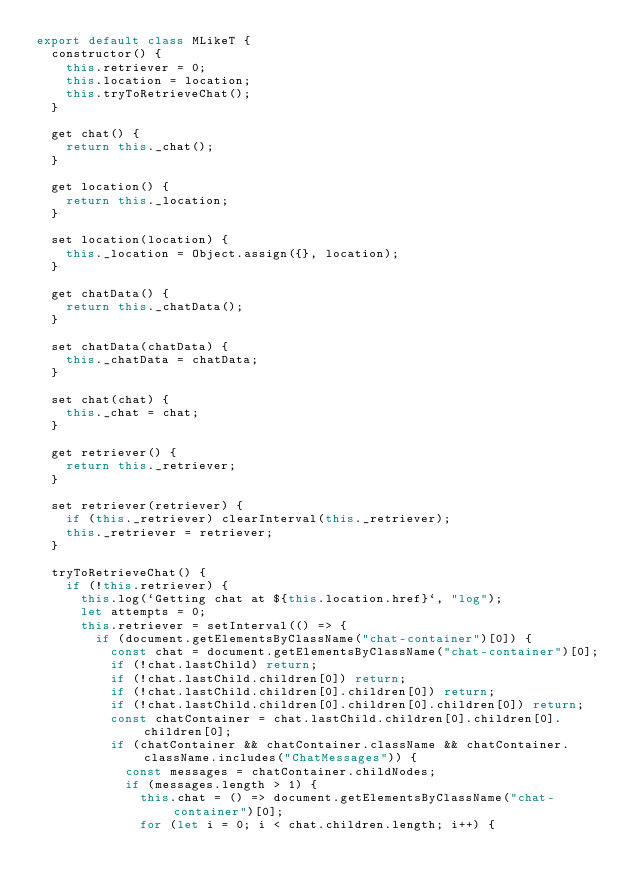Convert code to text. <code><loc_0><loc_0><loc_500><loc_500><_JavaScript_>export default class MLikeT {
  constructor() {
    this.retriever = 0;
    this.location = location;
    this.tryToRetrieveChat();
  }

  get chat() {
    return this._chat();
  }

  get location() {
    return this._location;
  }

  set location(location) {
    this._location = Object.assign({}, location);
  }

  get chatData() {
    return this._chatData();
  }

  set chatData(chatData) {
    this._chatData = chatData;
  }

  set chat(chat) {
    this._chat = chat;
  }

  get retriever() {
    return this._retriever;
  }

  set retriever(retriever) {
    if (this._retriever) clearInterval(this._retriever);
    this._retriever = retriever;
  }

  tryToRetrieveChat() {
    if (!this.retriever) {
      this.log(`Getting chat at ${this.location.href}`, "log");
      let attempts = 0;
      this.retriever = setInterval(() => {
        if (document.getElementsByClassName("chat-container")[0]) {
          const chat = document.getElementsByClassName("chat-container")[0];
          if (!chat.lastChild) return;
          if (!chat.lastChild.children[0]) return;
          if (!chat.lastChild.children[0].children[0]) return;
          if (!chat.lastChild.children[0].children[0].children[0]) return;
          const chatContainer = chat.lastChild.children[0].children[0].children[0];
          if (chatContainer && chatContainer.className && chatContainer.className.includes("ChatMessages")) {
            const messages = chatContainer.childNodes;
            if (messages.length > 1) {
              this.chat = () => document.getElementsByClassName("chat-container")[0];
              for (let i = 0; i < chat.children.length; i++) {</code> 